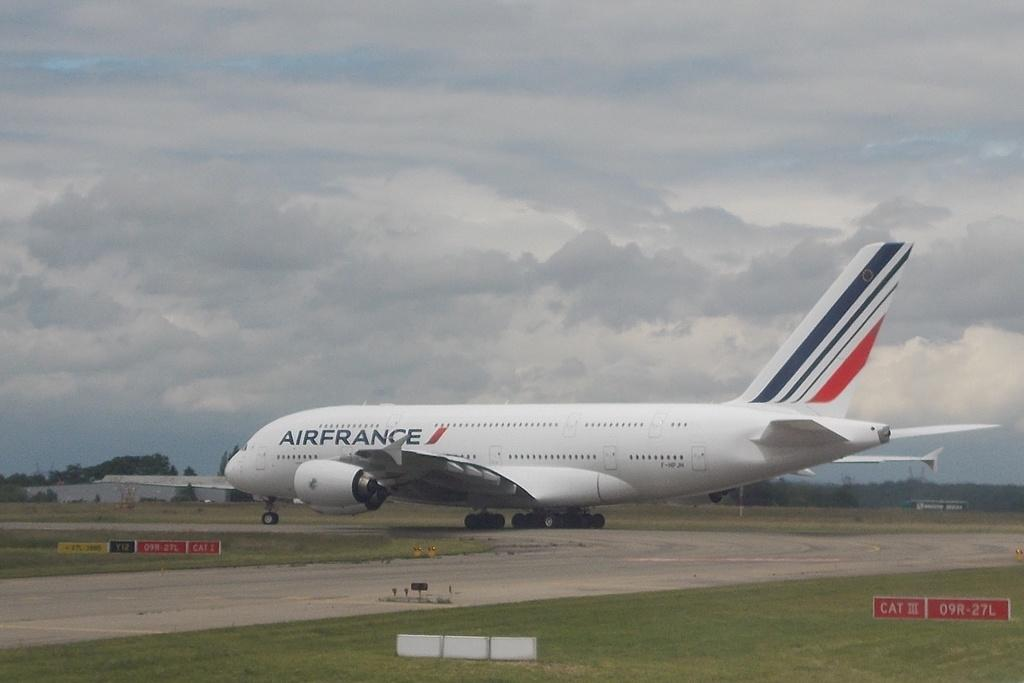Provide a one-sentence caption for the provided image. an AIRFRANCE airplane on a landing strip with the landing gear out. 